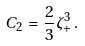<formula> <loc_0><loc_0><loc_500><loc_500>C _ { 2 } = \frac { 2 } { 3 } \zeta _ { + } ^ { 3 } \, .</formula> 